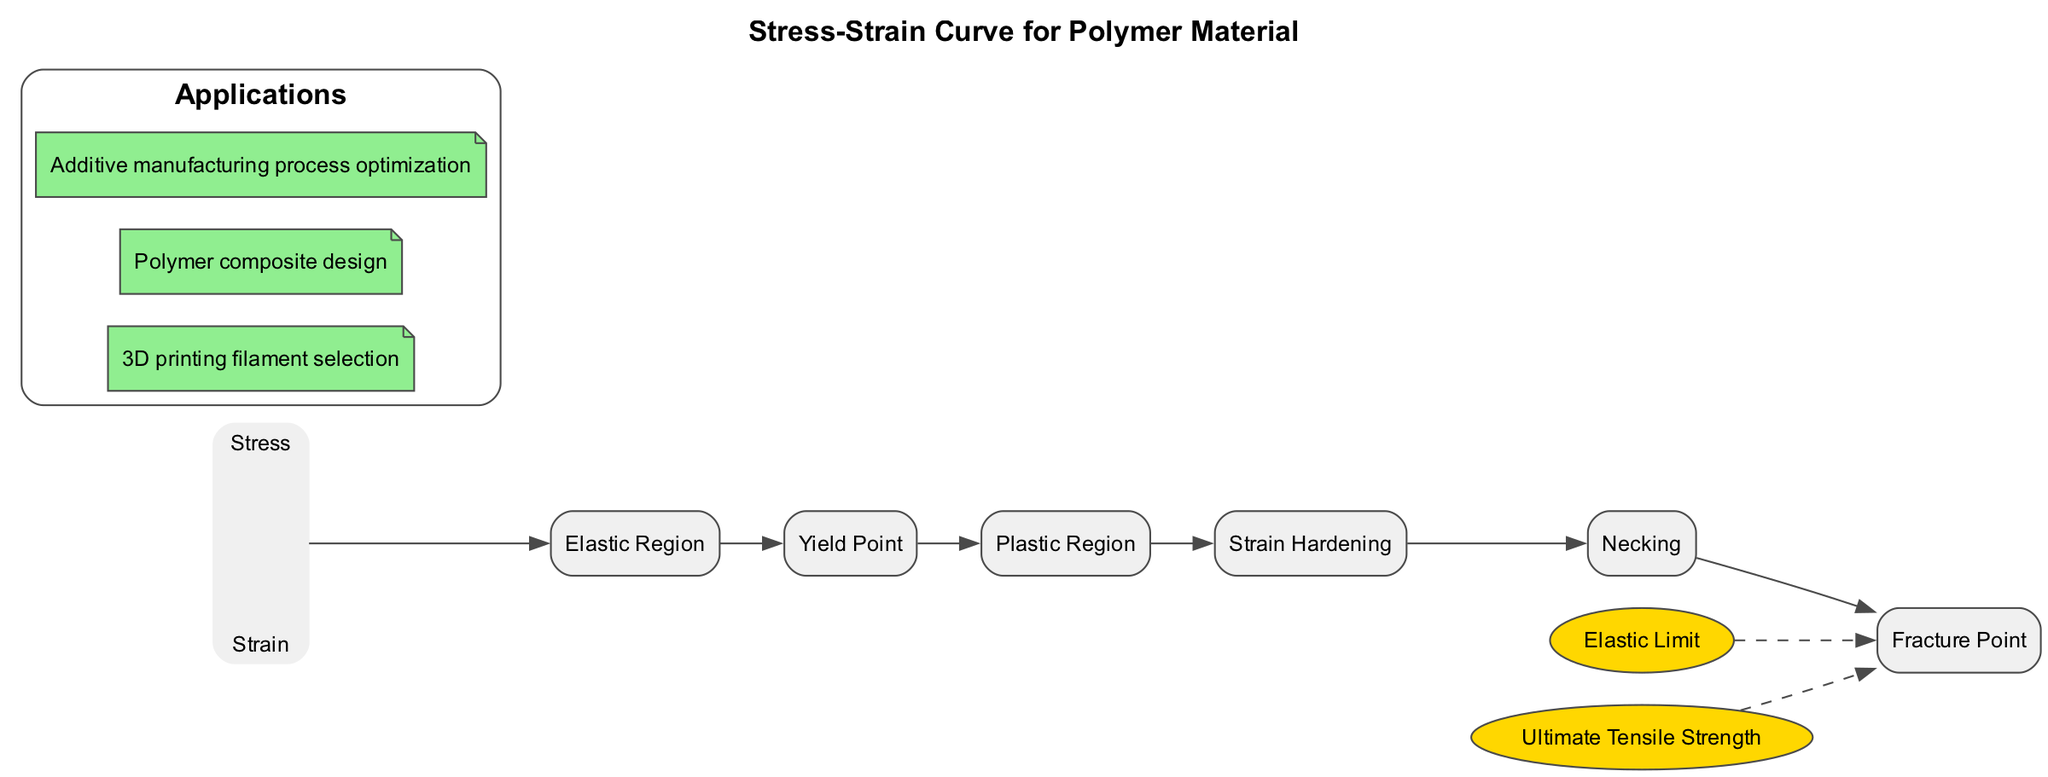What is the title of the diagram? The title is found prominently at the top of the diagram, indicating the content it represents. It clearly states "Stress-Strain Curve for Polymer Material."
Answer: Stress-Strain Curve for Polymer Material What are the axes labels in the diagram? The diagram includes two axes labeled: the vertical axis represents "Stress" and the horizontal axis represents "Strain." This information is usually noted near the axes lines.
Answer: Stress, Strain What is the name of the first segment in the curve? The first segment listed follows the axes and describes the relationship between stress and strain. It is labeled as the "Elastic Region."
Answer: Elastic Region What does the Yield Point signify? The Yield Point marks a specific point on the curve where the material transitions from elastic to plastic deformation, which is defined in the segment descriptions.
Answer: Transition from elastic to plastic deformation How many segments are in the curve? By counting the segments listed in the diagram, it is noted that there are a total of six segments present in the curve.
Answer: Six What is the ultimate tensile strength according to the diagram? The ultimate tensile strength is defined as the maximum stress that the polymer can withstand before failure, which is a key point mentioned specifically in the diagram.
Answer: Maximum stress the polymer can withstand What is the relationship between the Elastic Limit and permanent deformation? The Elastic Limit is a key point that indicates the maximum stress adhering to the material before it starts to undergo permanent deformation, highlighting its critical nature in material science.
Answer: Maximum stress without permanent deformation Why does the strength increase during the Strain Hardening phase? In the Strain Hardening segment of the curve, it is described that the strength of the polymer increases due to the alignment of polymer chains, which enhances the material's robustness under stress.
Answer: Due to chain alignment What type of applications does the diagram mention? The applications listed at the bottom of the diagram include "3D printing filament selection," "Polymer composite design," and "Additive manufacturing process optimization," succinctly summarizing practical uses of the stress-strain information.
Answer: 3D printing filament selection, Polymer composite design, Additive manufacturing process optimization 